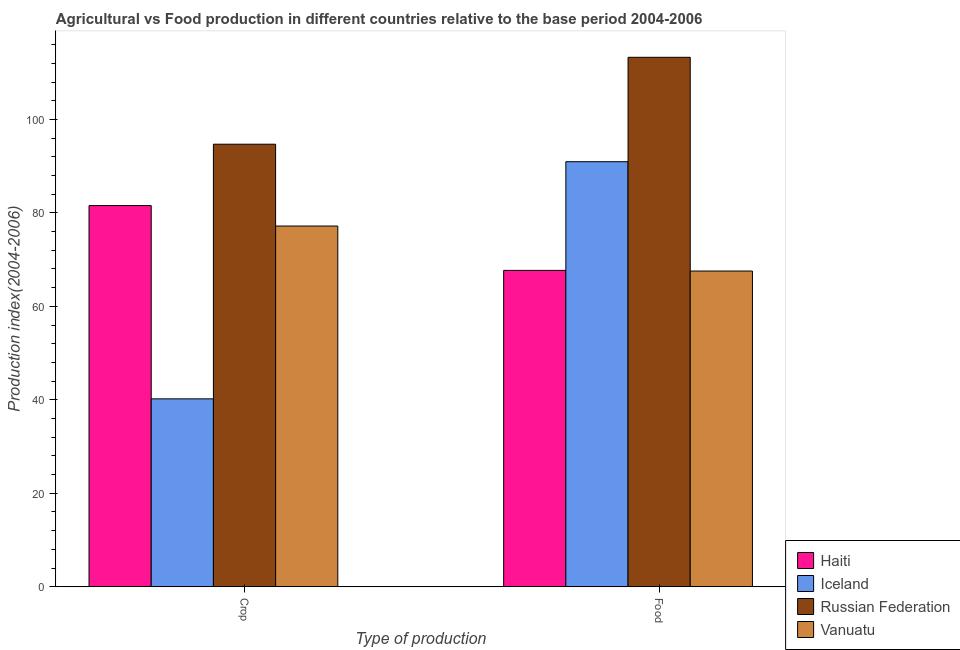How many bars are there on the 2nd tick from the left?
Offer a terse response. 4. How many bars are there on the 2nd tick from the right?
Your answer should be very brief. 4. What is the label of the 1st group of bars from the left?
Offer a terse response. Crop. What is the food production index in Russian Federation?
Offer a terse response. 113.3. Across all countries, what is the maximum food production index?
Your answer should be very brief. 113.3. Across all countries, what is the minimum crop production index?
Keep it short and to the point. 40.21. In which country was the crop production index maximum?
Your answer should be compact. Russian Federation. In which country was the food production index minimum?
Your answer should be very brief. Vanuatu. What is the total food production index in the graph?
Your answer should be compact. 339.52. What is the difference between the food production index in Russian Federation and that in Iceland?
Make the answer very short. 22.34. What is the difference between the crop production index in Haiti and the food production index in Russian Federation?
Keep it short and to the point. -31.73. What is the average crop production index per country?
Offer a terse response. 73.42. What is the difference between the crop production index and food production index in Vanuatu?
Keep it short and to the point. 9.63. What is the ratio of the food production index in Russian Federation to that in Vanuatu?
Give a very brief answer. 1.68. Is the crop production index in Vanuatu less than that in Russian Federation?
Give a very brief answer. Yes. What does the 3rd bar from the left in Food represents?
Your response must be concise. Russian Federation. What does the 1st bar from the right in Food represents?
Provide a succinct answer. Vanuatu. Are all the bars in the graph horizontal?
Your answer should be compact. No. How many countries are there in the graph?
Your answer should be compact. 4. Are the values on the major ticks of Y-axis written in scientific E-notation?
Give a very brief answer. No. Where does the legend appear in the graph?
Your response must be concise. Bottom right. What is the title of the graph?
Offer a terse response. Agricultural vs Food production in different countries relative to the base period 2004-2006. Does "Andorra" appear as one of the legend labels in the graph?
Give a very brief answer. No. What is the label or title of the X-axis?
Your response must be concise. Type of production. What is the label or title of the Y-axis?
Ensure brevity in your answer.  Production index(2004-2006). What is the Production index(2004-2006) in Haiti in Crop?
Provide a succinct answer. 81.57. What is the Production index(2004-2006) in Iceland in Crop?
Provide a succinct answer. 40.21. What is the Production index(2004-2006) of Russian Federation in Crop?
Give a very brief answer. 94.7. What is the Production index(2004-2006) in Vanuatu in Crop?
Give a very brief answer. 77.19. What is the Production index(2004-2006) in Haiti in Food?
Your answer should be very brief. 67.7. What is the Production index(2004-2006) of Iceland in Food?
Give a very brief answer. 90.96. What is the Production index(2004-2006) of Russian Federation in Food?
Your response must be concise. 113.3. What is the Production index(2004-2006) of Vanuatu in Food?
Give a very brief answer. 67.56. Across all Type of production, what is the maximum Production index(2004-2006) in Haiti?
Your answer should be very brief. 81.57. Across all Type of production, what is the maximum Production index(2004-2006) of Iceland?
Offer a very short reply. 90.96. Across all Type of production, what is the maximum Production index(2004-2006) of Russian Federation?
Offer a very short reply. 113.3. Across all Type of production, what is the maximum Production index(2004-2006) of Vanuatu?
Offer a very short reply. 77.19. Across all Type of production, what is the minimum Production index(2004-2006) in Haiti?
Make the answer very short. 67.7. Across all Type of production, what is the minimum Production index(2004-2006) of Iceland?
Provide a short and direct response. 40.21. Across all Type of production, what is the minimum Production index(2004-2006) of Russian Federation?
Keep it short and to the point. 94.7. Across all Type of production, what is the minimum Production index(2004-2006) of Vanuatu?
Ensure brevity in your answer.  67.56. What is the total Production index(2004-2006) in Haiti in the graph?
Offer a very short reply. 149.27. What is the total Production index(2004-2006) in Iceland in the graph?
Give a very brief answer. 131.17. What is the total Production index(2004-2006) of Russian Federation in the graph?
Ensure brevity in your answer.  208. What is the total Production index(2004-2006) in Vanuatu in the graph?
Offer a very short reply. 144.75. What is the difference between the Production index(2004-2006) in Haiti in Crop and that in Food?
Keep it short and to the point. 13.87. What is the difference between the Production index(2004-2006) of Iceland in Crop and that in Food?
Your answer should be very brief. -50.75. What is the difference between the Production index(2004-2006) of Russian Federation in Crop and that in Food?
Your response must be concise. -18.6. What is the difference between the Production index(2004-2006) of Vanuatu in Crop and that in Food?
Your answer should be compact. 9.63. What is the difference between the Production index(2004-2006) of Haiti in Crop and the Production index(2004-2006) of Iceland in Food?
Your answer should be very brief. -9.39. What is the difference between the Production index(2004-2006) in Haiti in Crop and the Production index(2004-2006) in Russian Federation in Food?
Your response must be concise. -31.73. What is the difference between the Production index(2004-2006) of Haiti in Crop and the Production index(2004-2006) of Vanuatu in Food?
Provide a short and direct response. 14.01. What is the difference between the Production index(2004-2006) of Iceland in Crop and the Production index(2004-2006) of Russian Federation in Food?
Ensure brevity in your answer.  -73.09. What is the difference between the Production index(2004-2006) of Iceland in Crop and the Production index(2004-2006) of Vanuatu in Food?
Provide a short and direct response. -27.35. What is the difference between the Production index(2004-2006) in Russian Federation in Crop and the Production index(2004-2006) in Vanuatu in Food?
Keep it short and to the point. 27.14. What is the average Production index(2004-2006) in Haiti per Type of production?
Ensure brevity in your answer.  74.64. What is the average Production index(2004-2006) in Iceland per Type of production?
Offer a terse response. 65.58. What is the average Production index(2004-2006) of Russian Federation per Type of production?
Provide a succinct answer. 104. What is the average Production index(2004-2006) of Vanuatu per Type of production?
Ensure brevity in your answer.  72.38. What is the difference between the Production index(2004-2006) of Haiti and Production index(2004-2006) of Iceland in Crop?
Your answer should be very brief. 41.36. What is the difference between the Production index(2004-2006) of Haiti and Production index(2004-2006) of Russian Federation in Crop?
Make the answer very short. -13.13. What is the difference between the Production index(2004-2006) of Haiti and Production index(2004-2006) of Vanuatu in Crop?
Keep it short and to the point. 4.38. What is the difference between the Production index(2004-2006) of Iceland and Production index(2004-2006) of Russian Federation in Crop?
Your answer should be very brief. -54.49. What is the difference between the Production index(2004-2006) of Iceland and Production index(2004-2006) of Vanuatu in Crop?
Give a very brief answer. -36.98. What is the difference between the Production index(2004-2006) in Russian Federation and Production index(2004-2006) in Vanuatu in Crop?
Your answer should be very brief. 17.51. What is the difference between the Production index(2004-2006) in Haiti and Production index(2004-2006) in Iceland in Food?
Keep it short and to the point. -23.26. What is the difference between the Production index(2004-2006) of Haiti and Production index(2004-2006) of Russian Federation in Food?
Offer a very short reply. -45.6. What is the difference between the Production index(2004-2006) of Haiti and Production index(2004-2006) of Vanuatu in Food?
Offer a terse response. 0.14. What is the difference between the Production index(2004-2006) of Iceland and Production index(2004-2006) of Russian Federation in Food?
Offer a very short reply. -22.34. What is the difference between the Production index(2004-2006) in Iceland and Production index(2004-2006) in Vanuatu in Food?
Keep it short and to the point. 23.4. What is the difference between the Production index(2004-2006) in Russian Federation and Production index(2004-2006) in Vanuatu in Food?
Make the answer very short. 45.74. What is the ratio of the Production index(2004-2006) of Haiti in Crop to that in Food?
Your answer should be very brief. 1.2. What is the ratio of the Production index(2004-2006) of Iceland in Crop to that in Food?
Offer a very short reply. 0.44. What is the ratio of the Production index(2004-2006) in Russian Federation in Crop to that in Food?
Ensure brevity in your answer.  0.84. What is the ratio of the Production index(2004-2006) in Vanuatu in Crop to that in Food?
Provide a short and direct response. 1.14. What is the difference between the highest and the second highest Production index(2004-2006) of Haiti?
Your response must be concise. 13.87. What is the difference between the highest and the second highest Production index(2004-2006) in Iceland?
Your answer should be very brief. 50.75. What is the difference between the highest and the second highest Production index(2004-2006) in Russian Federation?
Make the answer very short. 18.6. What is the difference between the highest and the second highest Production index(2004-2006) of Vanuatu?
Provide a succinct answer. 9.63. What is the difference between the highest and the lowest Production index(2004-2006) in Haiti?
Your answer should be very brief. 13.87. What is the difference between the highest and the lowest Production index(2004-2006) of Iceland?
Make the answer very short. 50.75. What is the difference between the highest and the lowest Production index(2004-2006) in Russian Federation?
Keep it short and to the point. 18.6. What is the difference between the highest and the lowest Production index(2004-2006) in Vanuatu?
Offer a very short reply. 9.63. 